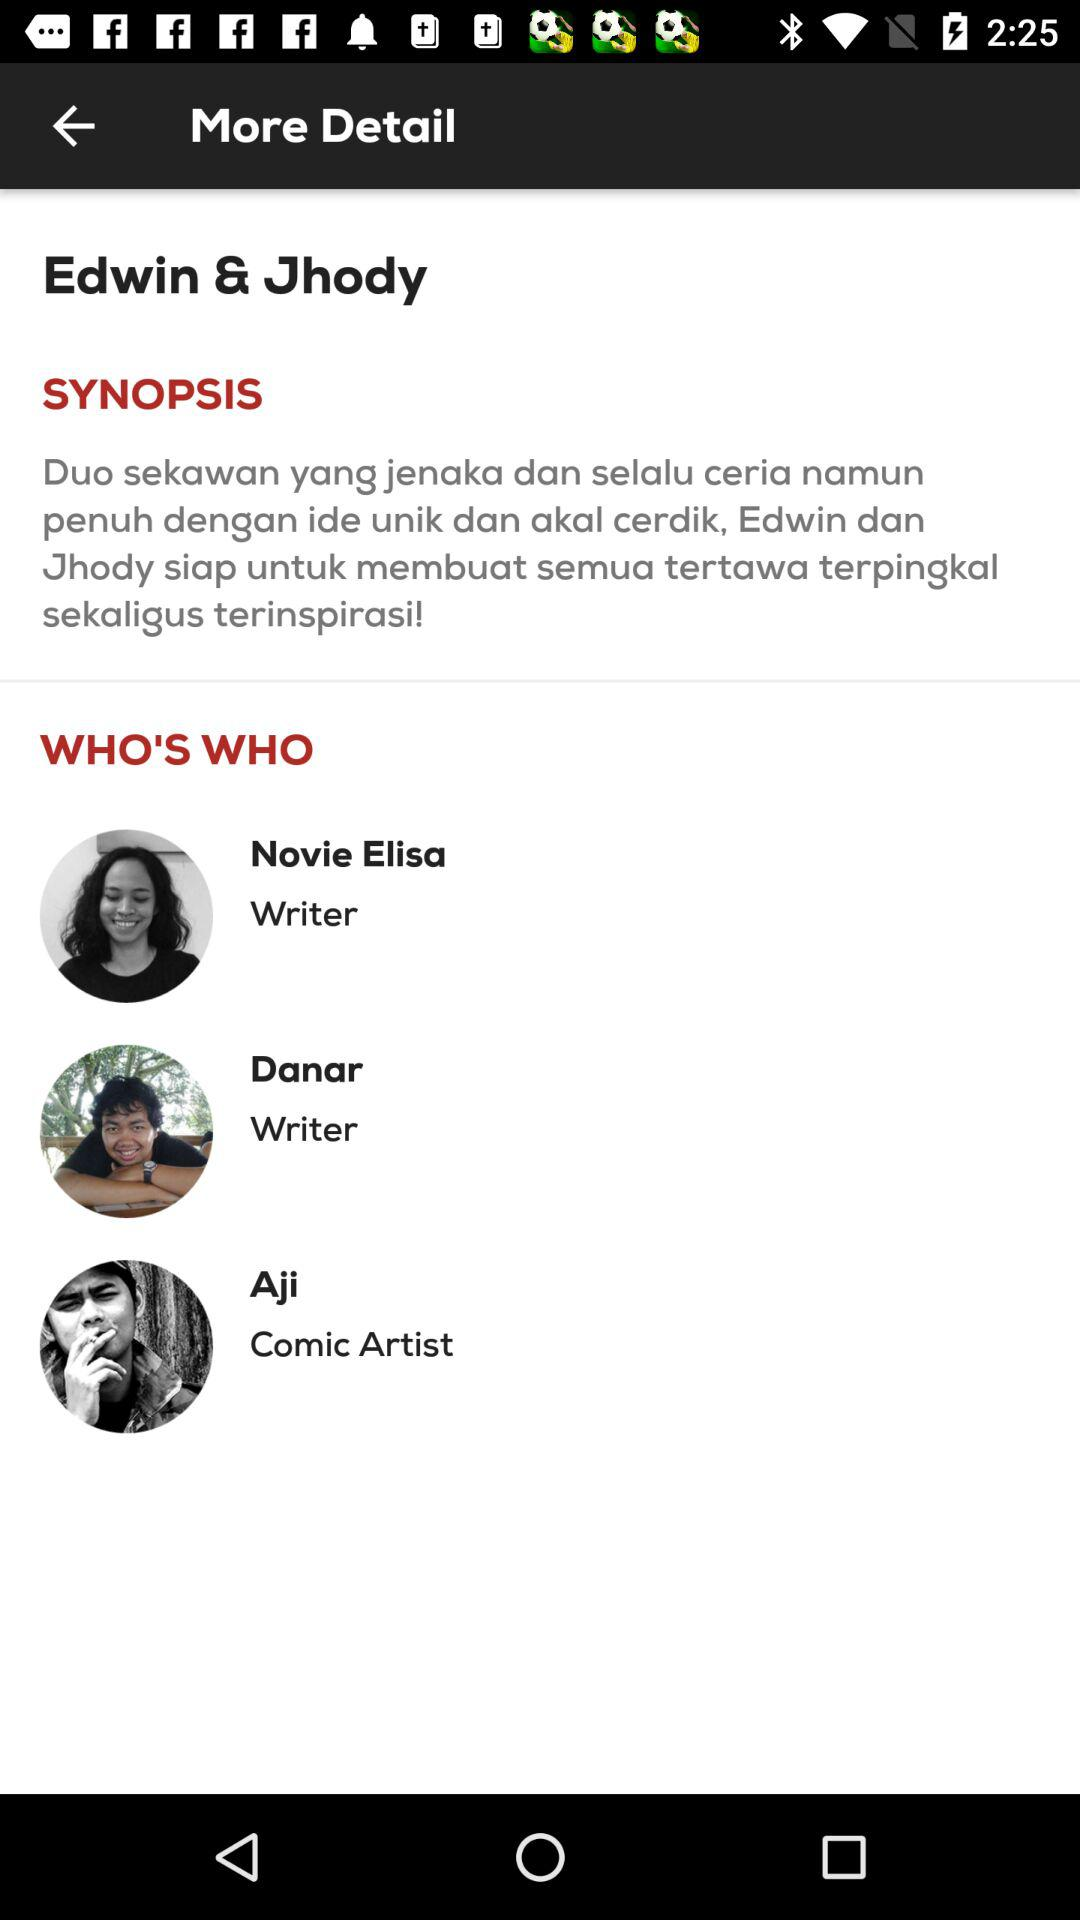How many people are credited as writers?
Answer the question using a single word or phrase. 3 